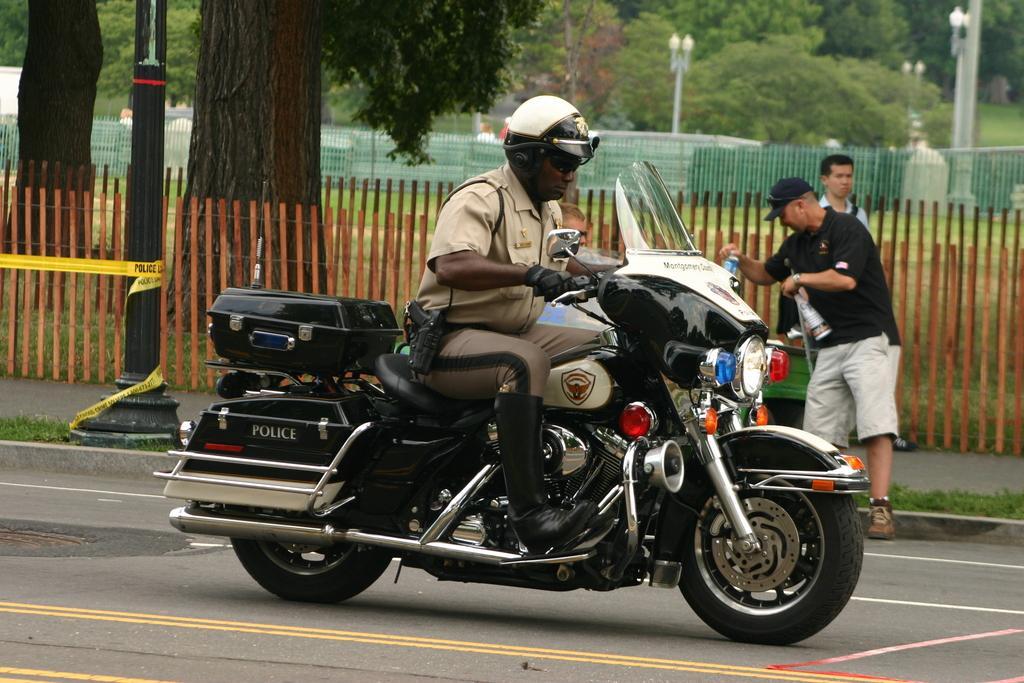Please provide a concise description of this image. In this picture a man is riding a police bike. 